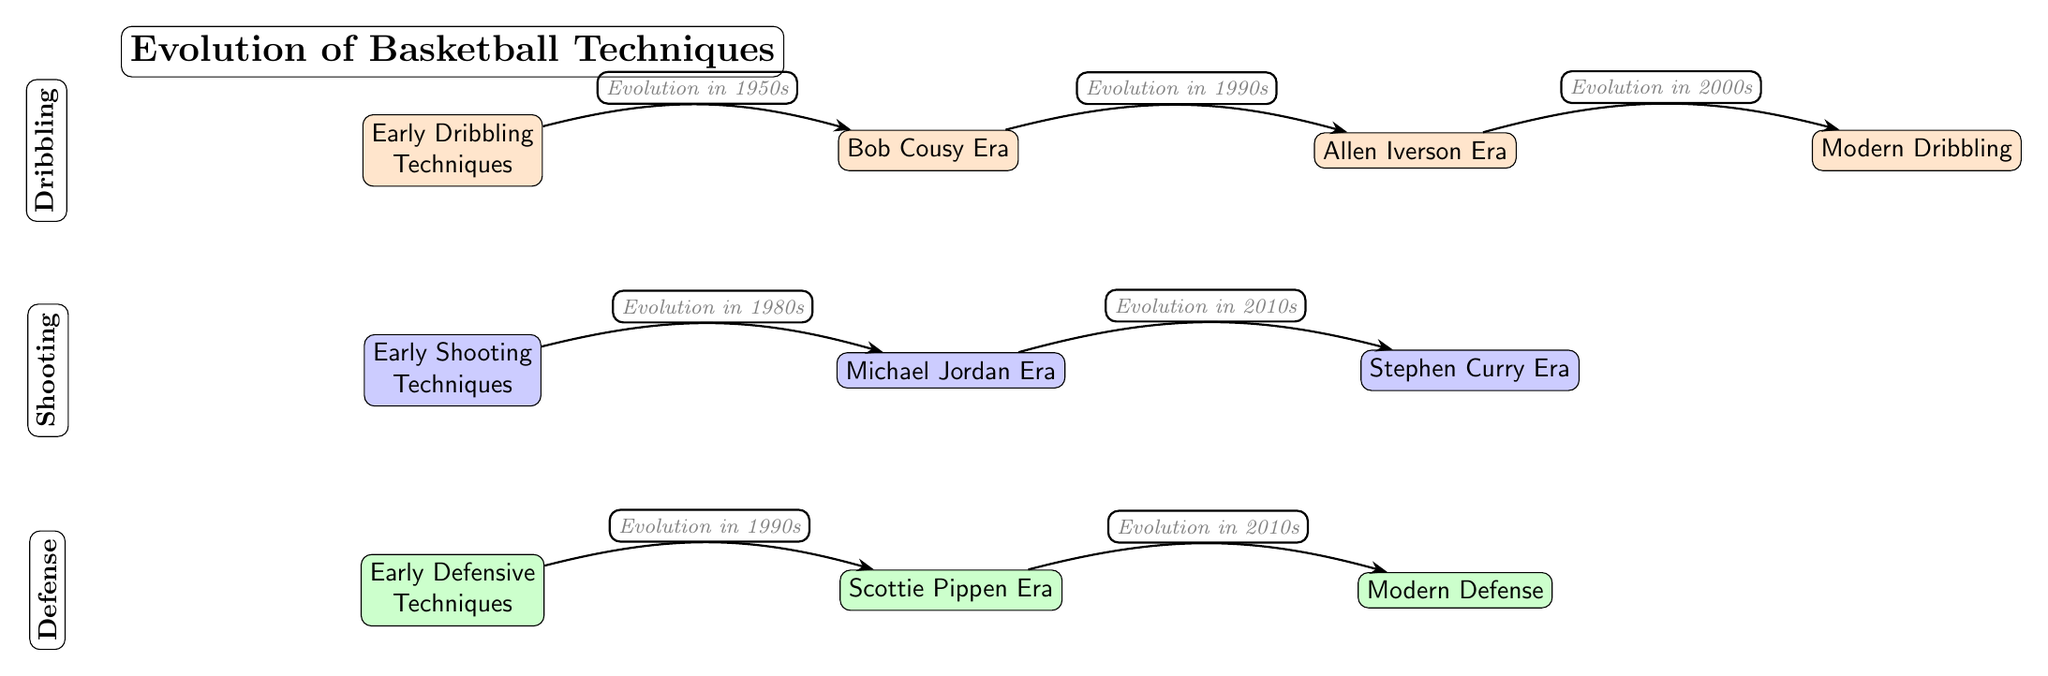What decades are represented in the evolution of dribbling techniques? The diagram indicates that dribbling techniques evolved through four key decades: the early techniques in the 1950s, Bob Cousy's era, Allen Iverson's era in the 1990s, and modern dribbling in the 2000s. By examining the nodes, we can see the dates associated with the arrows.
Answer: 1950s, 1990s, 2000s What type of techniques are listed under the shooting category? In the shooting category, the diagram shows three types: "Early Shooting Techniques," "Michael Jordan Era," and "Stephen Curry Era." Each of these nodes represents a specific evolution of shooting techniques over time.
Answer: Early Shooting Techniques, Michael Jordan Era, Stephen Curry Era Which player is associated with the evolution of shooting techniques in the 1980s? The diagram clearly indicates that Michael Jordan is the player associated with the evolution of shooting techniques in the 1980s, as shown by the arrow connecting the "Early Shooting Techniques" node to the "Michael Jordan Era" node.
Answer: Michael Jordan How many nodes represent defensive techniques evolution? There are three nodes that represent the evolution of defensive techniques: "Early Defensive Techniques," "Scottie Pippen Era," and "Modern Defense." By counting these nodes in the defense section of the diagram, we can easily determine the number.
Answer: 3 Which player is noted for influencing defensive techniques in the 1990s? Scottie Pippen is recognized for his influence on defensive techniques in the 1990s, as shown by the arrow linking "Early Defensive Techniques" to "Scottie Pippen Era" in the diagram.
Answer: Scottie Pippen What relationship exists between Allen Iverson Era and Modern Dribbling? The relationship is an evolutionary one depicted by the arrow showing the progression from the "Allen Iverson Era," indicating that the evolution in dribbling techniques led to the "Modern Dribbling" techniques.
Answer: Evolution Which era marks the beginning of modern shooting techniques? The diagram suggests that shooting techniques transitioned into the modern era with Stephen Curry in the 2010s, as indicated by the arrow connecting the "Michael Jordan Era" to the "Stephen Curry Era."
Answer: 2010s How many types of techniques are represented in the diagram? Looking at the diagram, there are three types of techniques represented: Dribbling, Shooting, and Defense. Each of these categories has its own evolutionary path depicted in the diagram.
Answer: 3 What decade was influential for both shooting and defense techniques? The 1990s are significant for both shooting and defense techniques, as shown by the evolution arrows pointing to influential players during that time: Allen Iverson for dribbling and Scottie Pippen for defense.
Answer: 1990s 